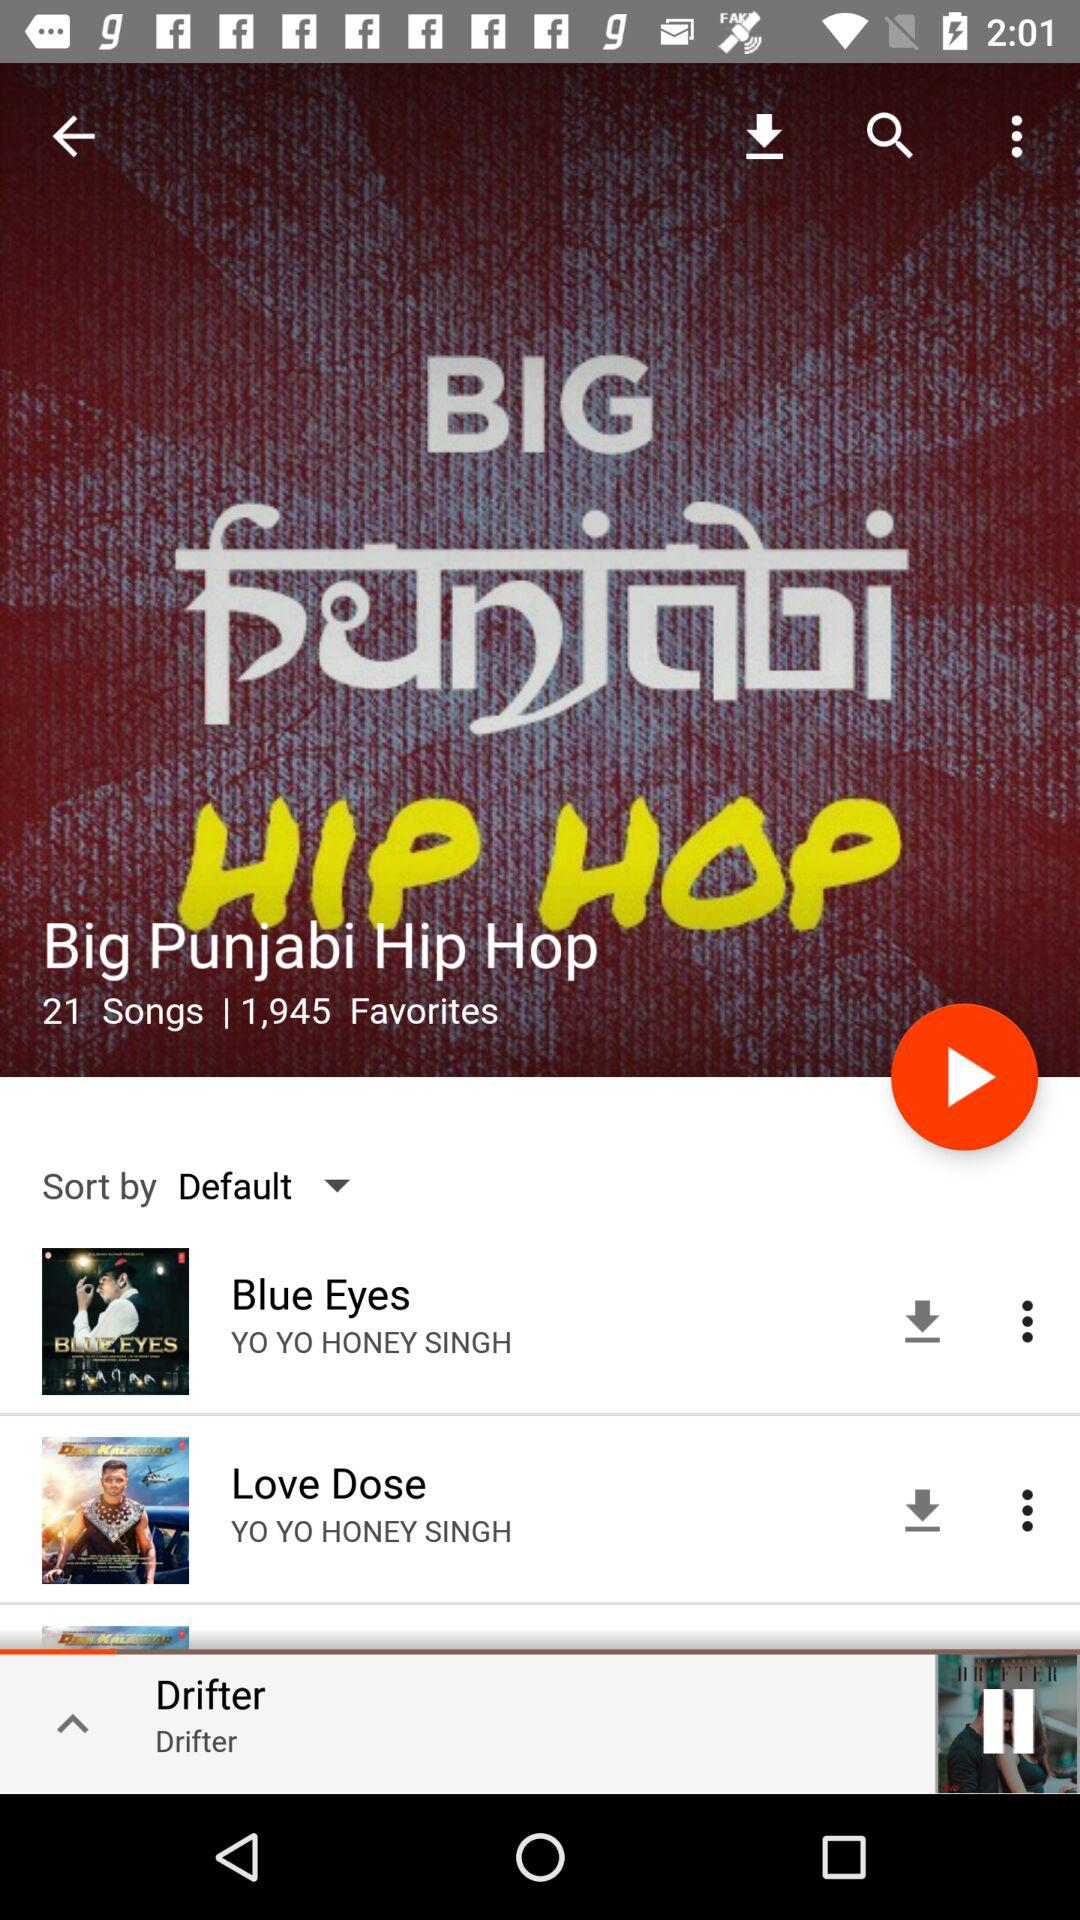Which song is playing? The song is "Drifter". 